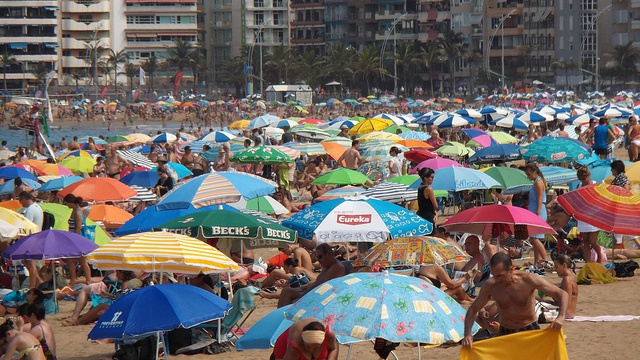Describe the objects in this image and their specific colors. I can see people in gray, black, and maroon tones, umbrella in gray, lightgray, blue, darkgray, and darkblue tones, umbrella in gray, lightblue, teal, and ivory tones, umbrella in gray, lightgray, lightblue, teal, and darkgray tones, and umbrella in gray, teal, blue, darkgray, and black tones in this image. 